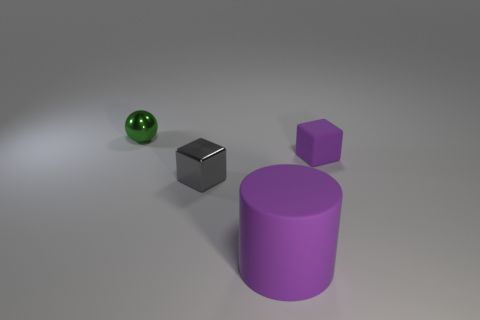Add 2 green blocks. How many objects exist? 6 Subtract all spheres. How many objects are left? 3 Subtract all purple cubes. Subtract all big purple metal spheres. How many objects are left? 3 Add 1 green metallic spheres. How many green metallic spheres are left? 2 Add 4 big cylinders. How many big cylinders exist? 5 Subtract 0 red cylinders. How many objects are left? 4 